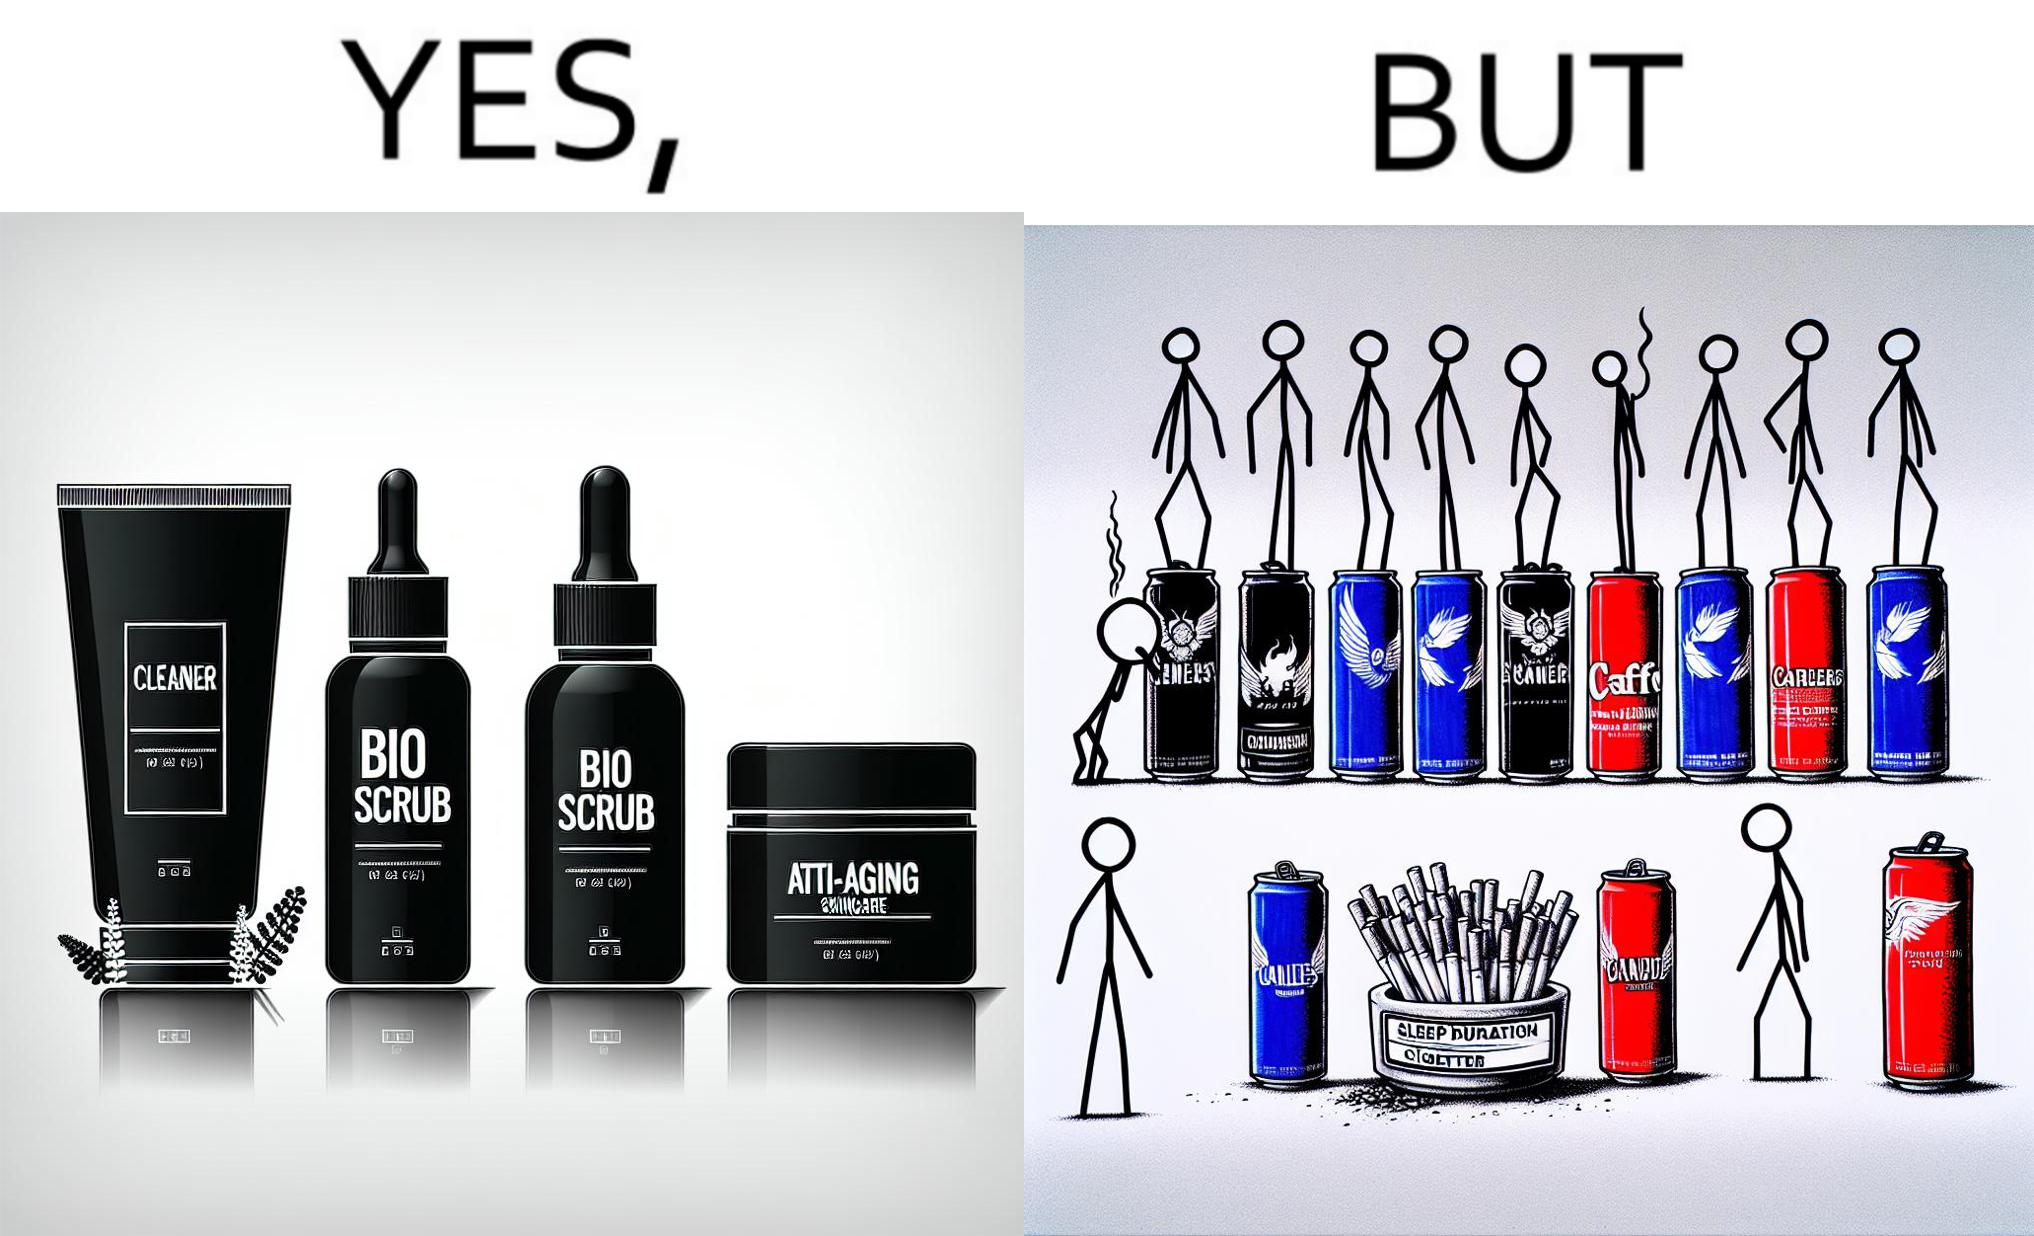Describe the contrast between the left and right parts of this image. In the left part of the image: 4 Skincare products, arranged aesthetically. A tube labeled "Cleaner". A tube labeled "BIO SCRUB". A dropper bottle labeled "HYDRATING GEL". A jar called "ANTI-AGING SKINCARE". In the right part of the image: 9 cans of red bull, some standing upright, some crushed. Cans have blue and red colors. An ashtray with many cigarette butts in it and has smoke coming out. A banner that says "Sleep duration 2h 5min". 